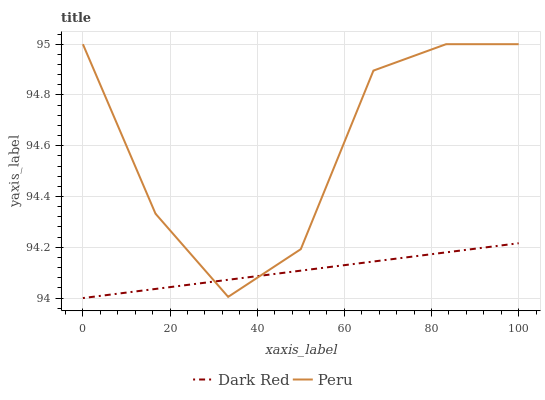Does Dark Red have the minimum area under the curve?
Answer yes or no. Yes. Does Peru have the maximum area under the curve?
Answer yes or no. Yes. Does Peru have the minimum area under the curve?
Answer yes or no. No. Is Dark Red the smoothest?
Answer yes or no. Yes. Is Peru the roughest?
Answer yes or no. Yes. Is Peru the smoothest?
Answer yes or no. No. Does Dark Red have the lowest value?
Answer yes or no. Yes. Does Peru have the lowest value?
Answer yes or no. No. Does Peru have the highest value?
Answer yes or no. Yes. Does Dark Red intersect Peru?
Answer yes or no. Yes. Is Dark Red less than Peru?
Answer yes or no. No. Is Dark Red greater than Peru?
Answer yes or no. No. 